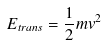Convert formula to latex. <formula><loc_0><loc_0><loc_500><loc_500>E _ { t r a n s } = \frac { 1 } { 2 } m v ^ { 2 }</formula> 